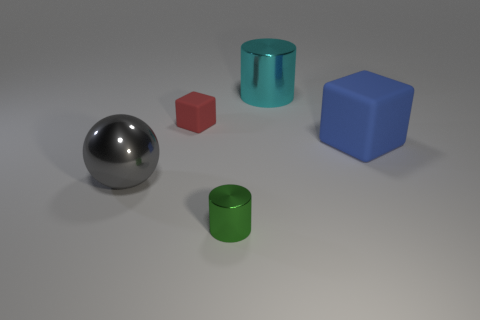Add 3 large cyan things. How many objects exist? 8 Subtract all cylinders. How many objects are left? 3 Subtract 2 cylinders. How many cylinders are left? 0 Subtract all green cylinders. How many cylinders are left? 1 Subtract 1 green cylinders. How many objects are left? 4 Subtract all yellow cylinders. Subtract all green balls. How many cylinders are left? 2 Subtract all tiny matte blocks. Subtract all large metal cylinders. How many objects are left? 3 Add 5 tiny cubes. How many tiny cubes are left? 6 Add 4 big brown matte spheres. How many big brown matte spheres exist? 4 